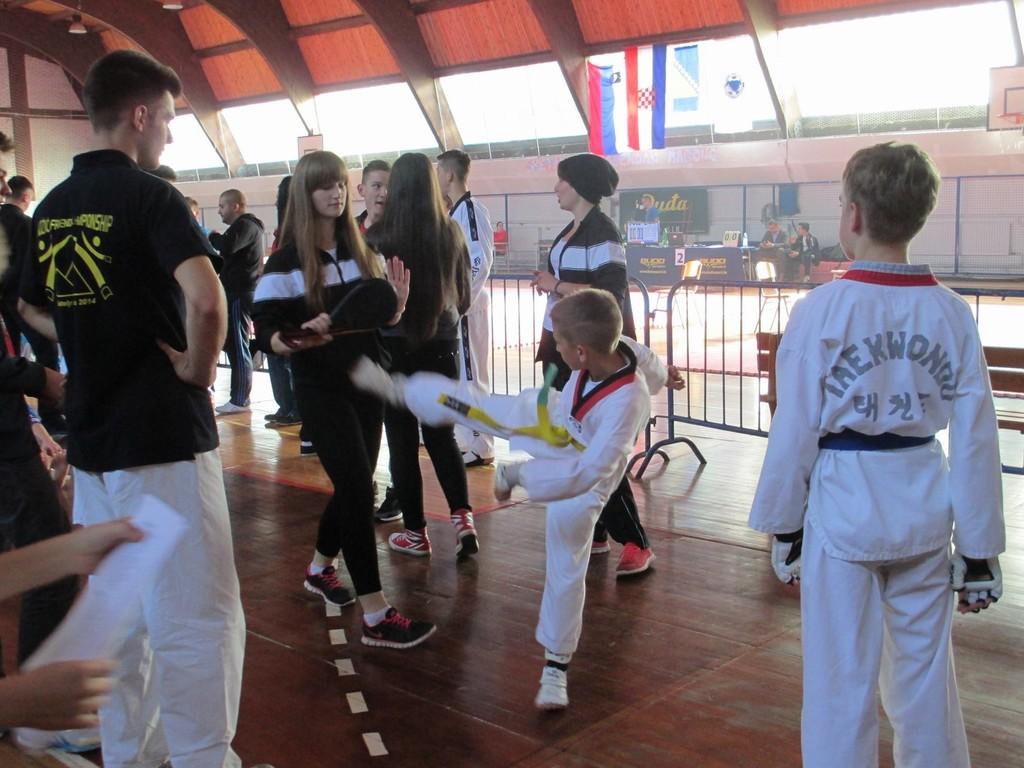Are they in taekwondo?
Your answer should be very brief. Yes. What does his shirt say?
Provide a succinct answer. Taekwondo. 